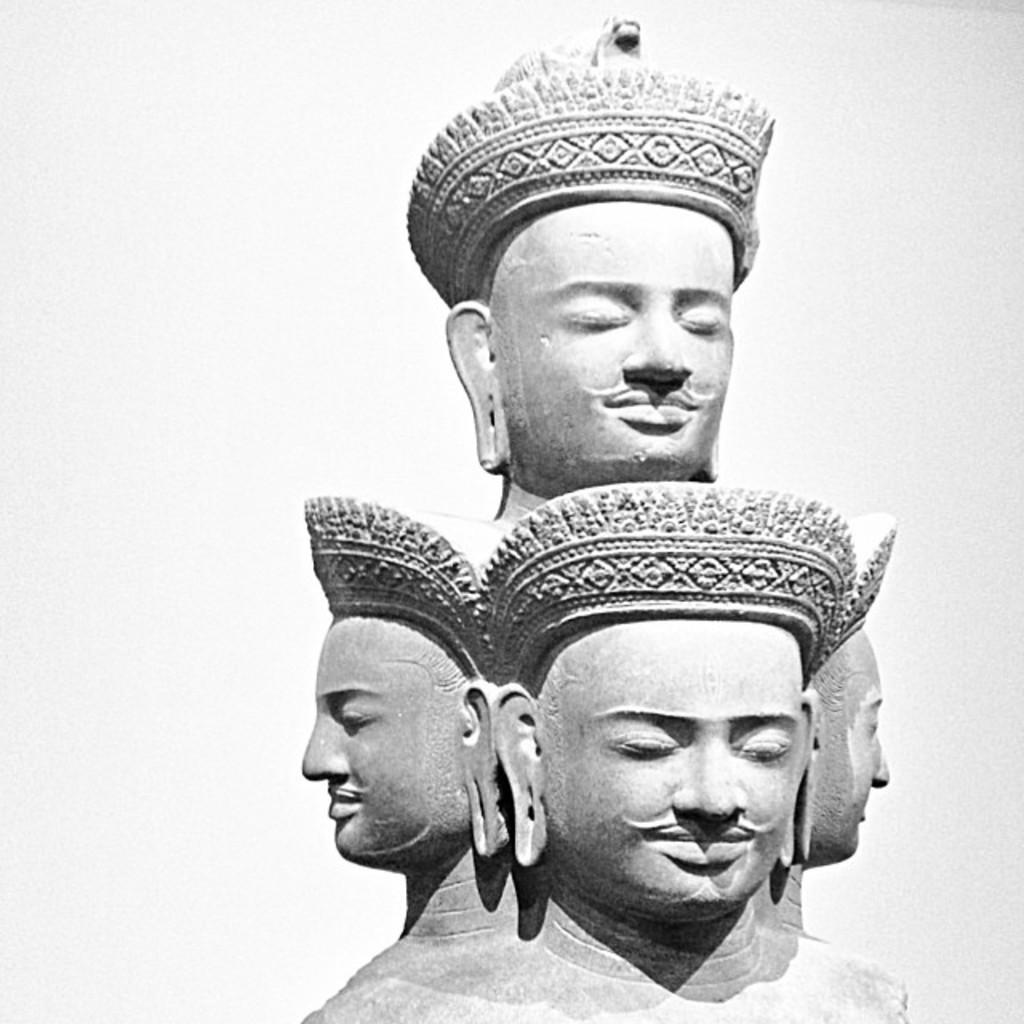What is the main subject of the image? There is a sculpture in the image. Can you describe the sculpture in more detail? The sculpture consists of three heads side by side, and each of the three heads has a crown. Is there anything else notable about the sculpture? Yes, there is a fourth head on top of the other three heads, and this fourth head also has a crown. What type of watch is the fourth head wearing in the image? There is no watch present in the image; the fourth head is wearing a crown, as mentioned in the facts. 